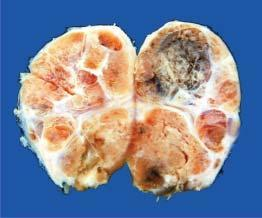s iron enlarged and nodular?
Answer the question using a single word or phrase. No 